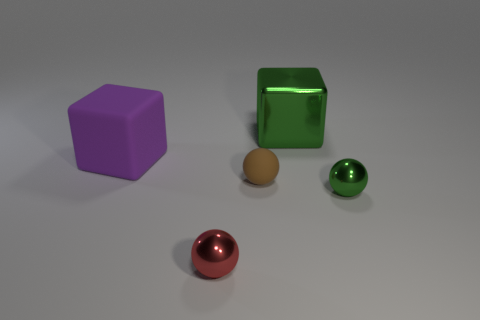Subtract all tiny red metallic balls. How many balls are left? 2 Add 3 big green metal blocks. How many objects exist? 8 Subtract all brown balls. How many balls are left? 2 Subtract 1 balls. How many balls are left? 2 Subtract all spheres. How many objects are left? 2 Add 2 large yellow shiny cylinders. How many large yellow shiny cylinders exist? 2 Subtract 0 brown cylinders. How many objects are left? 5 Subtract all blue cubes. Subtract all green cylinders. How many cubes are left? 2 Subtract all large gray metallic cylinders. Subtract all small rubber balls. How many objects are left? 4 Add 2 big matte blocks. How many big matte blocks are left? 3 